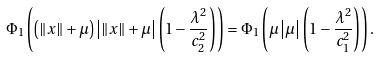<formula> <loc_0><loc_0><loc_500><loc_500>\Phi _ { 1 } \left ( \left ( \left \| x \right \| + \mu \right ) \left | \left \| x \right \| + \mu \right | \left ( 1 - \frac { \lambda ^ { 2 } } { c _ { 2 } ^ { 2 } } \right ) \right ) = \Phi _ { 1 } \left ( \mu \left | \mu \right | \left ( 1 - \frac { \lambda ^ { 2 } } { c _ { 1 } ^ { 2 } } \right ) \right ) .</formula> 